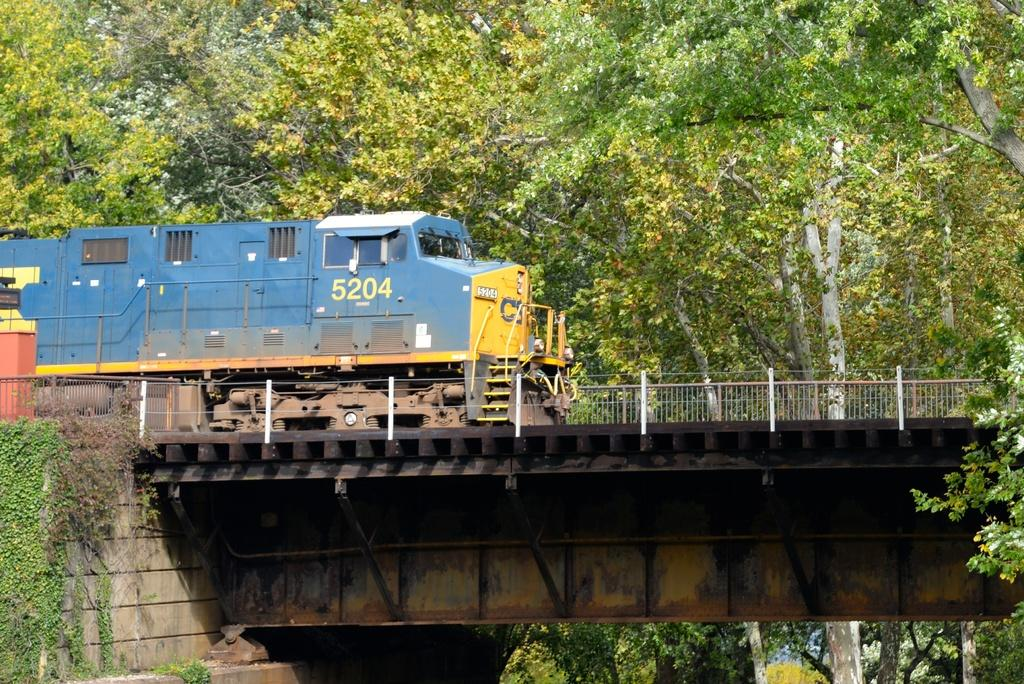<image>
Render a clear and concise summary of the photo. Blue train with the number 5204 on it on top of a bridge. 